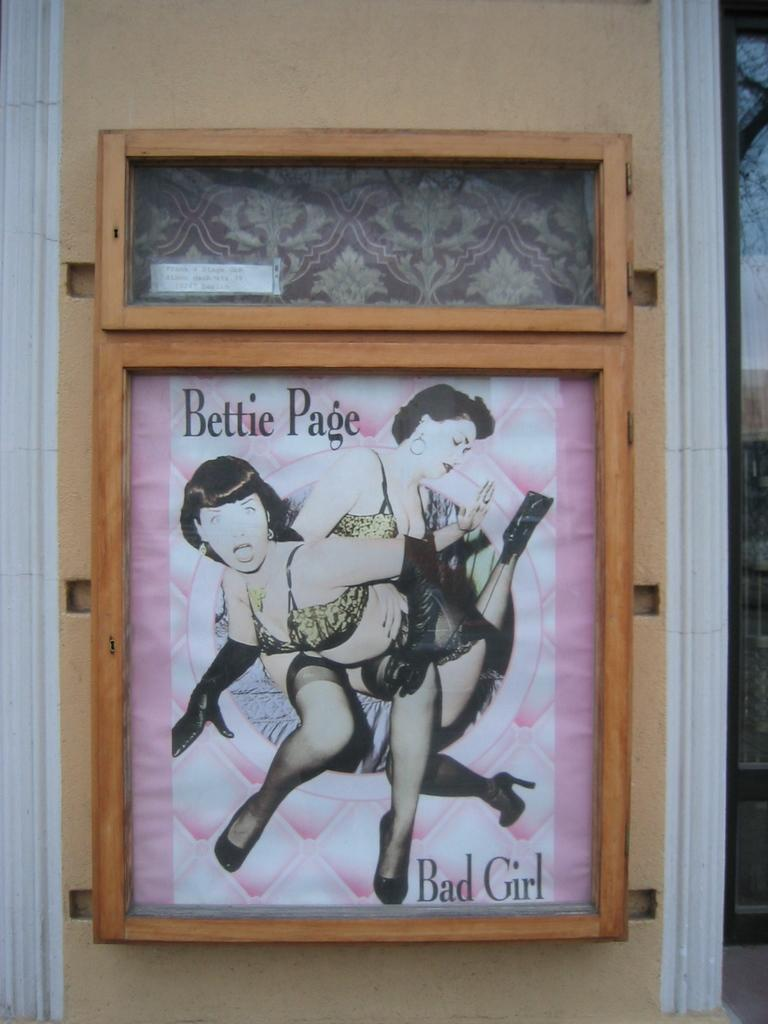<image>
Share a concise interpretation of the image provided. A poster framed in wood of Bettie Page 